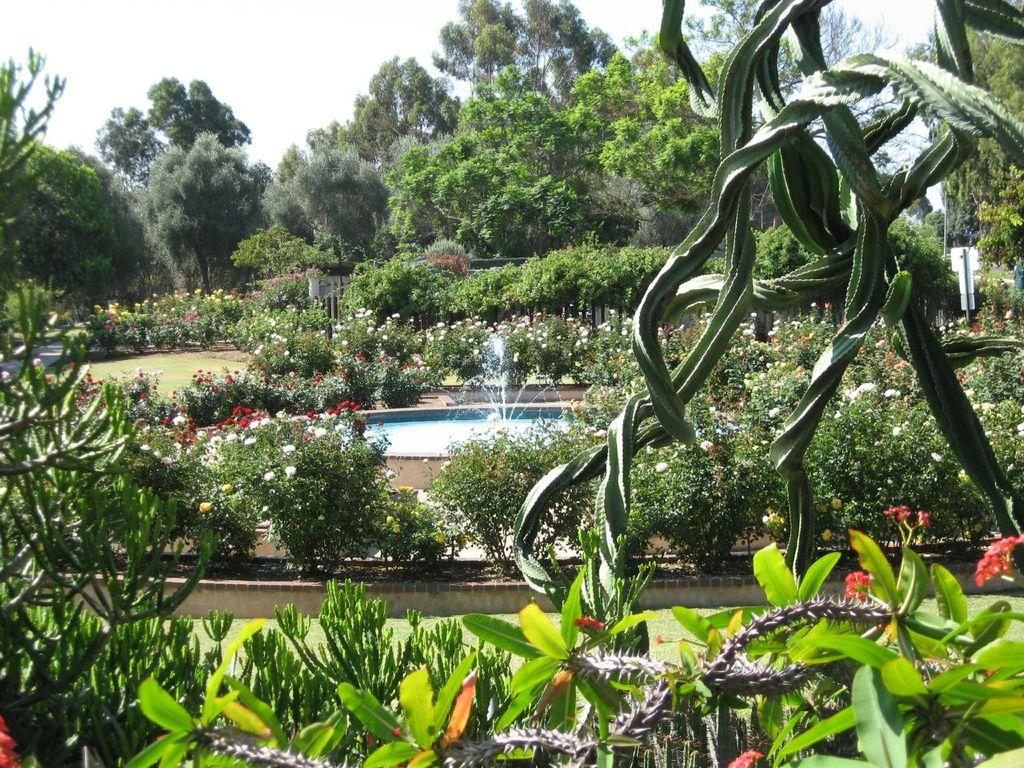What type of living organisms can be seen in the image? Plants can be seen in the image. What feature of the plants is particularly noticeable? The plants have colorful flowers. What additional feature is present in the image? There is a fountain in the image. What can be seen in the background of the image? Trees and the sky are visible in the background of the image. What type of disease is affecting the arm of the man in the image? There is no man or arm present in the image, so it is not possible to determine if a disease is affecting them. 